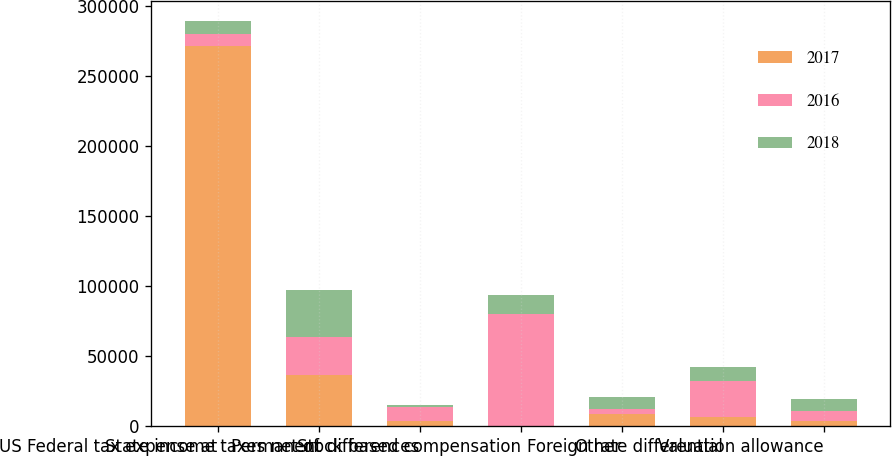<chart> <loc_0><loc_0><loc_500><loc_500><stacked_bar_chart><ecel><fcel>US Federal tax expense at<fcel>State income taxes net of<fcel>Permanent differences<fcel>Stock based compensation<fcel>Other<fcel>Foreign rate differential<fcel>Valuation allowance<nl><fcel>2017<fcel>271587<fcel>36312<fcel>3606<fcel>370<fcel>8438<fcel>6405<fcel>3976<nl><fcel>2016<fcel>8885<fcel>27569<fcel>10356<fcel>79687<fcel>3736<fcel>25895<fcel>6764<nl><fcel>2018<fcel>8885<fcel>33148<fcel>954<fcel>13654<fcel>8765<fcel>9720<fcel>8885<nl></chart> 